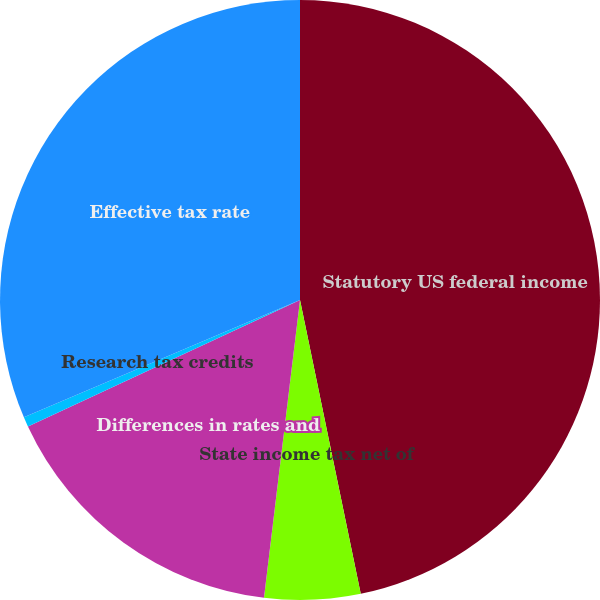<chart> <loc_0><loc_0><loc_500><loc_500><pie_chart><fcel>Statutory US federal income<fcel>State income tax net of<fcel>Differences in rates and<fcel>Research tax credits<fcel>Effective tax rate<nl><fcel>46.75%<fcel>5.16%<fcel>16.16%<fcel>0.53%<fcel>31.39%<nl></chart> 